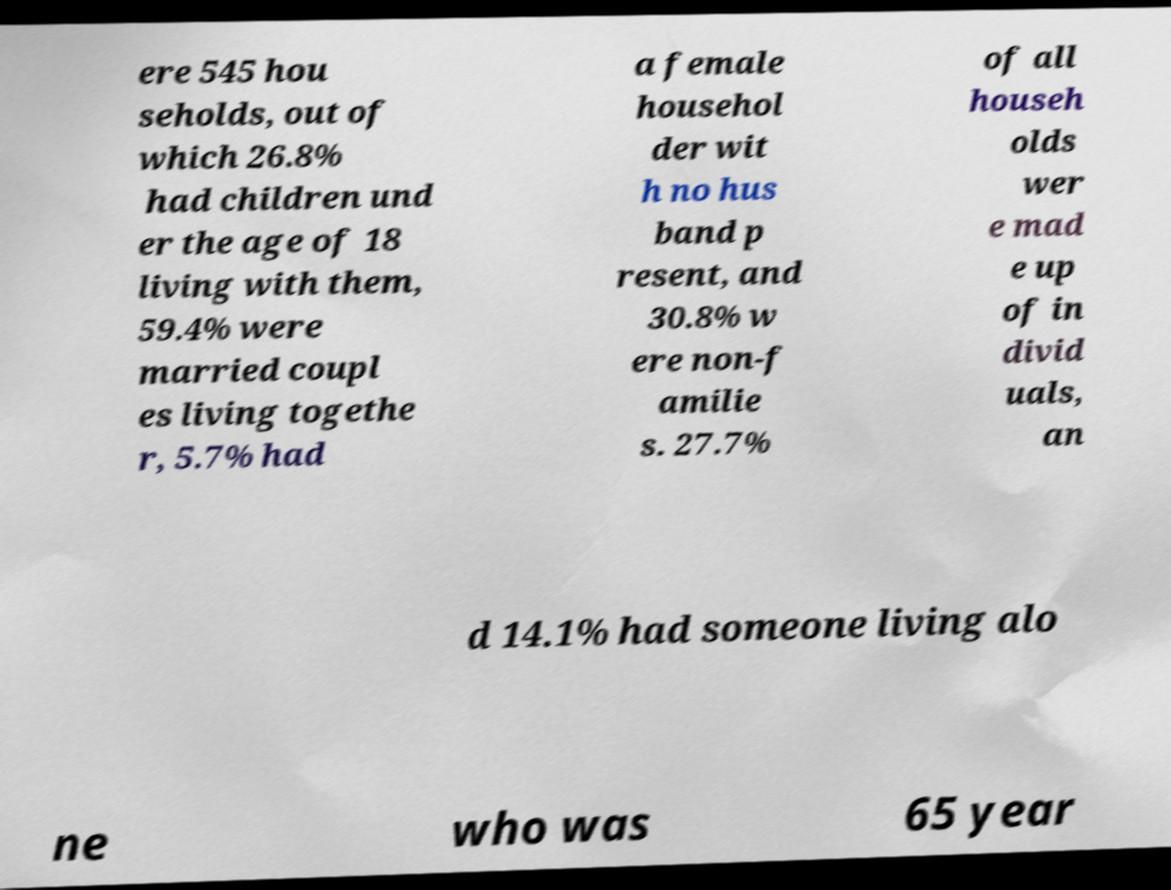For documentation purposes, I need the text within this image transcribed. Could you provide that? ere 545 hou seholds, out of which 26.8% had children und er the age of 18 living with them, 59.4% were married coupl es living togethe r, 5.7% had a female househol der wit h no hus band p resent, and 30.8% w ere non-f amilie s. 27.7% of all househ olds wer e mad e up of in divid uals, an d 14.1% had someone living alo ne who was 65 year 